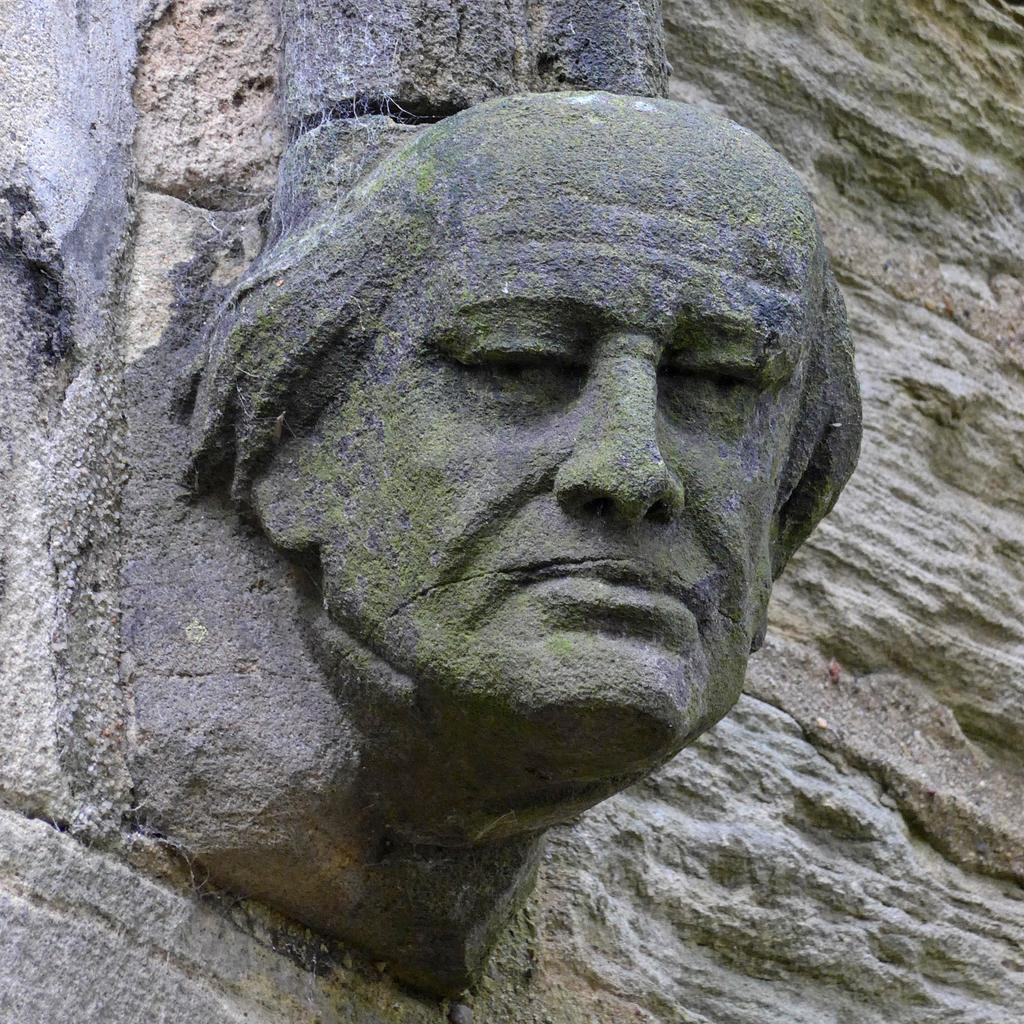What is the main subject of the image? There is a depiction of a person in the image. Where is the person located in the image? The person is depicted on a rock. What type of patch is visible on the person's clothing in the image? There is no patch visible on the person's clothing in the image. How many drops of water can be seen falling from the sun in the image? There is no sun or water drops present in the image. 